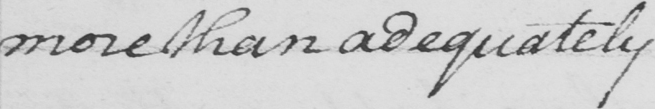Transcribe the text shown in this historical manuscript line. more than adequately 